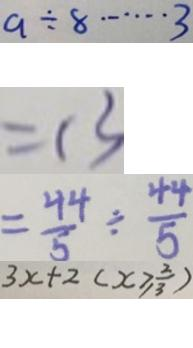Convert formula to latex. <formula><loc_0><loc_0><loc_500><loc_500>a \div 8 \cdots 3 
 = 1 3 
 = \frac { 4 4 } { 5 } \div \frac { 4 4 } { 5 } 
 3 x + 2 ( x \geq \frac { 2 } { 3 } )</formula> 